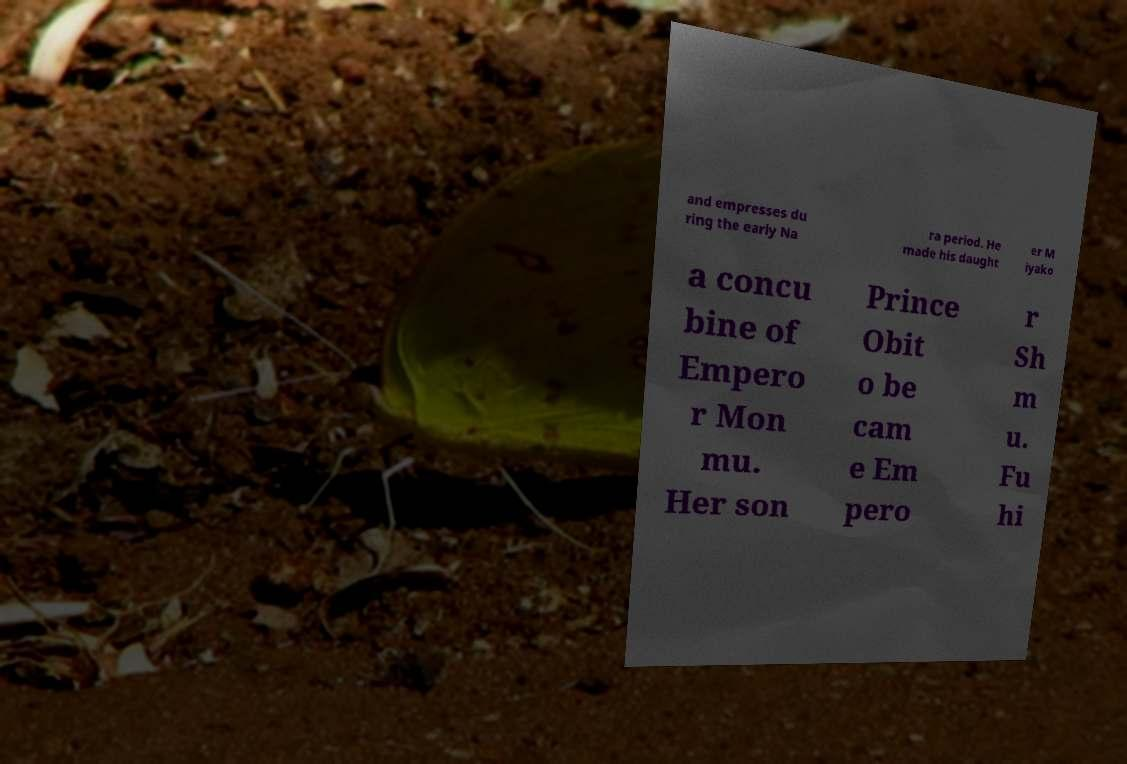Could you extract and type out the text from this image? and empresses du ring the early Na ra period. He made his daught er M iyako a concu bine of Empero r Mon mu. Her son Prince Obit o be cam e Em pero r Sh m u. Fu hi 